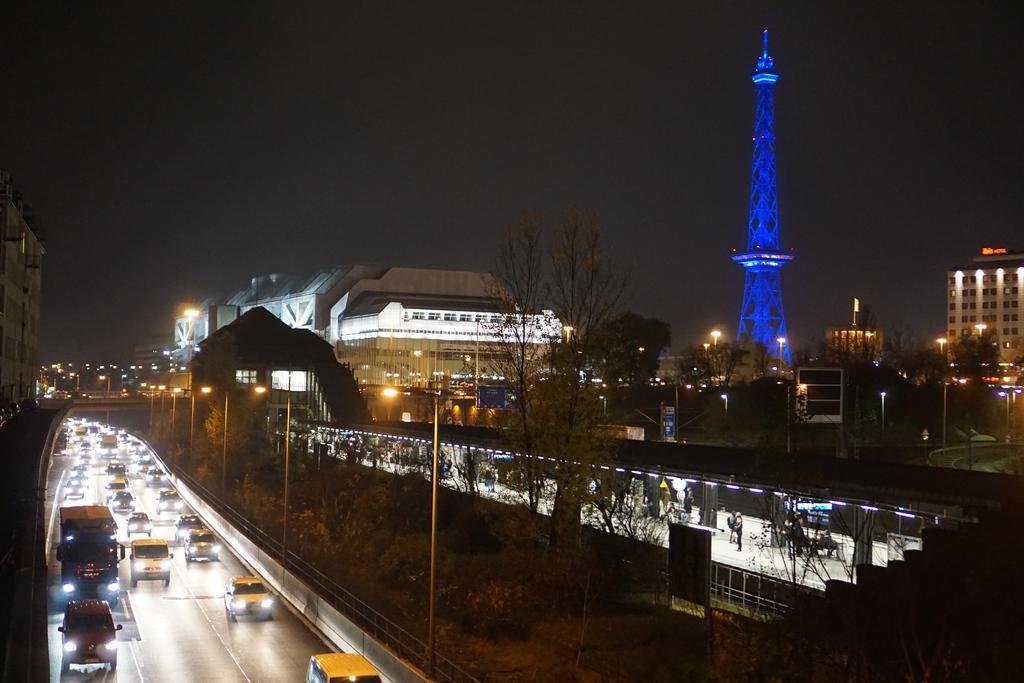In one or two sentences, can you explain what this image depicts? At the top there is a sky. Here we can see vehicles on the road. Here we can see buildings and trees. This is a tower. 